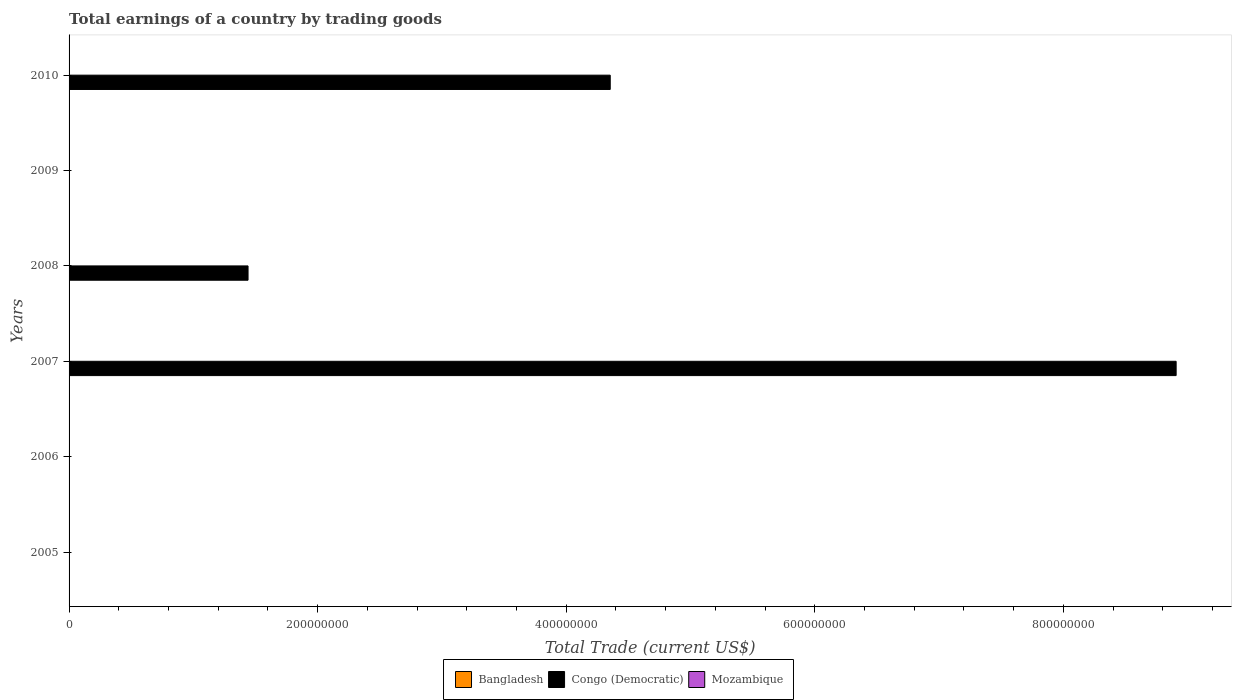Are the number of bars per tick equal to the number of legend labels?
Provide a succinct answer. No. Are the number of bars on each tick of the Y-axis equal?
Your response must be concise. No. How many bars are there on the 5th tick from the top?
Your answer should be very brief. 0. In how many cases, is the number of bars for a given year not equal to the number of legend labels?
Provide a short and direct response. 6. What is the total earnings in Congo (Democratic) in 2008?
Provide a short and direct response. 1.44e+08. Across all years, what is the maximum total earnings in Congo (Democratic)?
Your answer should be very brief. 8.91e+08. Across all years, what is the minimum total earnings in Congo (Democratic)?
Provide a succinct answer. 0. What is the total total earnings in Congo (Democratic) in the graph?
Ensure brevity in your answer.  1.47e+09. What is the difference between the total earnings in Congo (Democratic) in 2007 and that in 2008?
Offer a terse response. 7.47e+08. What is the difference between the total earnings in Bangladesh in 2008 and the total earnings in Congo (Democratic) in 2007?
Provide a short and direct response. -8.91e+08. What is the average total earnings in Congo (Democratic) per year?
Give a very brief answer. 2.45e+08. In how many years, is the total earnings in Bangladesh greater than 320000000 US$?
Your answer should be very brief. 0. What is the difference between the highest and the second highest total earnings in Congo (Democratic)?
Offer a terse response. 4.55e+08. Are all the bars in the graph horizontal?
Provide a succinct answer. Yes. What is the difference between two consecutive major ticks on the X-axis?
Keep it short and to the point. 2.00e+08. Are the values on the major ticks of X-axis written in scientific E-notation?
Your answer should be very brief. No. Where does the legend appear in the graph?
Provide a succinct answer. Bottom center. How many legend labels are there?
Provide a succinct answer. 3. What is the title of the graph?
Make the answer very short. Total earnings of a country by trading goods. What is the label or title of the X-axis?
Make the answer very short. Total Trade (current US$). What is the Total Trade (current US$) in Bangladesh in 2005?
Your answer should be compact. 0. What is the Total Trade (current US$) in Congo (Democratic) in 2005?
Give a very brief answer. 0. What is the Total Trade (current US$) of Mozambique in 2005?
Your answer should be very brief. 0. What is the Total Trade (current US$) in Bangladesh in 2006?
Your response must be concise. 0. What is the Total Trade (current US$) in Mozambique in 2006?
Make the answer very short. 0. What is the Total Trade (current US$) in Congo (Democratic) in 2007?
Ensure brevity in your answer.  8.91e+08. What is the Total Trade (current US$) of Congo (Democratic) in 2008?
Your answer should be very brief. 1.44e+08. What is the Total Trade (current US$) in Mozambique in 2008?
Provide a succinct answer. 0. What is the Total Trade (current US$) in Bangladesh in 2009?
Your response must be concise. 0. What is the Total Trade (current US$) in Congo (Democratic) in 2010?
Offer a very short reply. 4.35e+08. What is the Total Trade (current US$) of Mozambique in 2010?
Offer a terse response. 0. Across all years, what is the maximum Total Trade (current US$) in Congo (Democratic)?
Give a very brief answer. 8.91e+08. Across all years, what is the minimum Total Trade (current US$) of Congo (Democratic)?
Offer a terse response. 0. What is the total Total Trade (current US$) in Congo (Democratic) in the graph?
Offer a very short reply. 1.47e+09. What is the total Total Trade (current US$) of Mozambique in the graph?
Give a very brief answer. 0. What is the difference between the Total Trade (current US$) in Congo (Democratic) in 2007 and that in 2008?
Offer a terse response. 7.47e+08. What is the difference between the Total Trade (current US$) of Congo (Democratic) in 2007 and that in 2010?
Your answer should be compact. 4.55e+08. What is the difference between the Total Trade (current US$) in Congo (Democratic) in 2008 and that in 2010?
Offer a very short reply. -2.91e+08. What is the average Total Trade (current US$) in Congo (Democratic) per year?
Ensure brevity in your answer.  2.45e+08. What is the ratio of the Total Trade (current US$) in Congo (Democratic) in 2007 to that in 2008?
Offer a very short reply. 6.19. What is the ratio of the Total Trade (current US$) in Congo (Democratic) in 2007 to that in 2010?
Offer a very short reply. 2.05. What is the ratio of the Total Trade (current US$) in Congo (Democratic) in 2008 to that in 2010?
Offer a very short reply. 0.33. What is the difference between the highest and the second highest Total Trade (current US$) of Congo (Democratic)?
Offer a very short reply. 4.55e+08. What is the difference between the highest and the lowest Total Trade (current US$) in Congo (Democratic)?
Provide a succinct answer. 8.91e+08. 